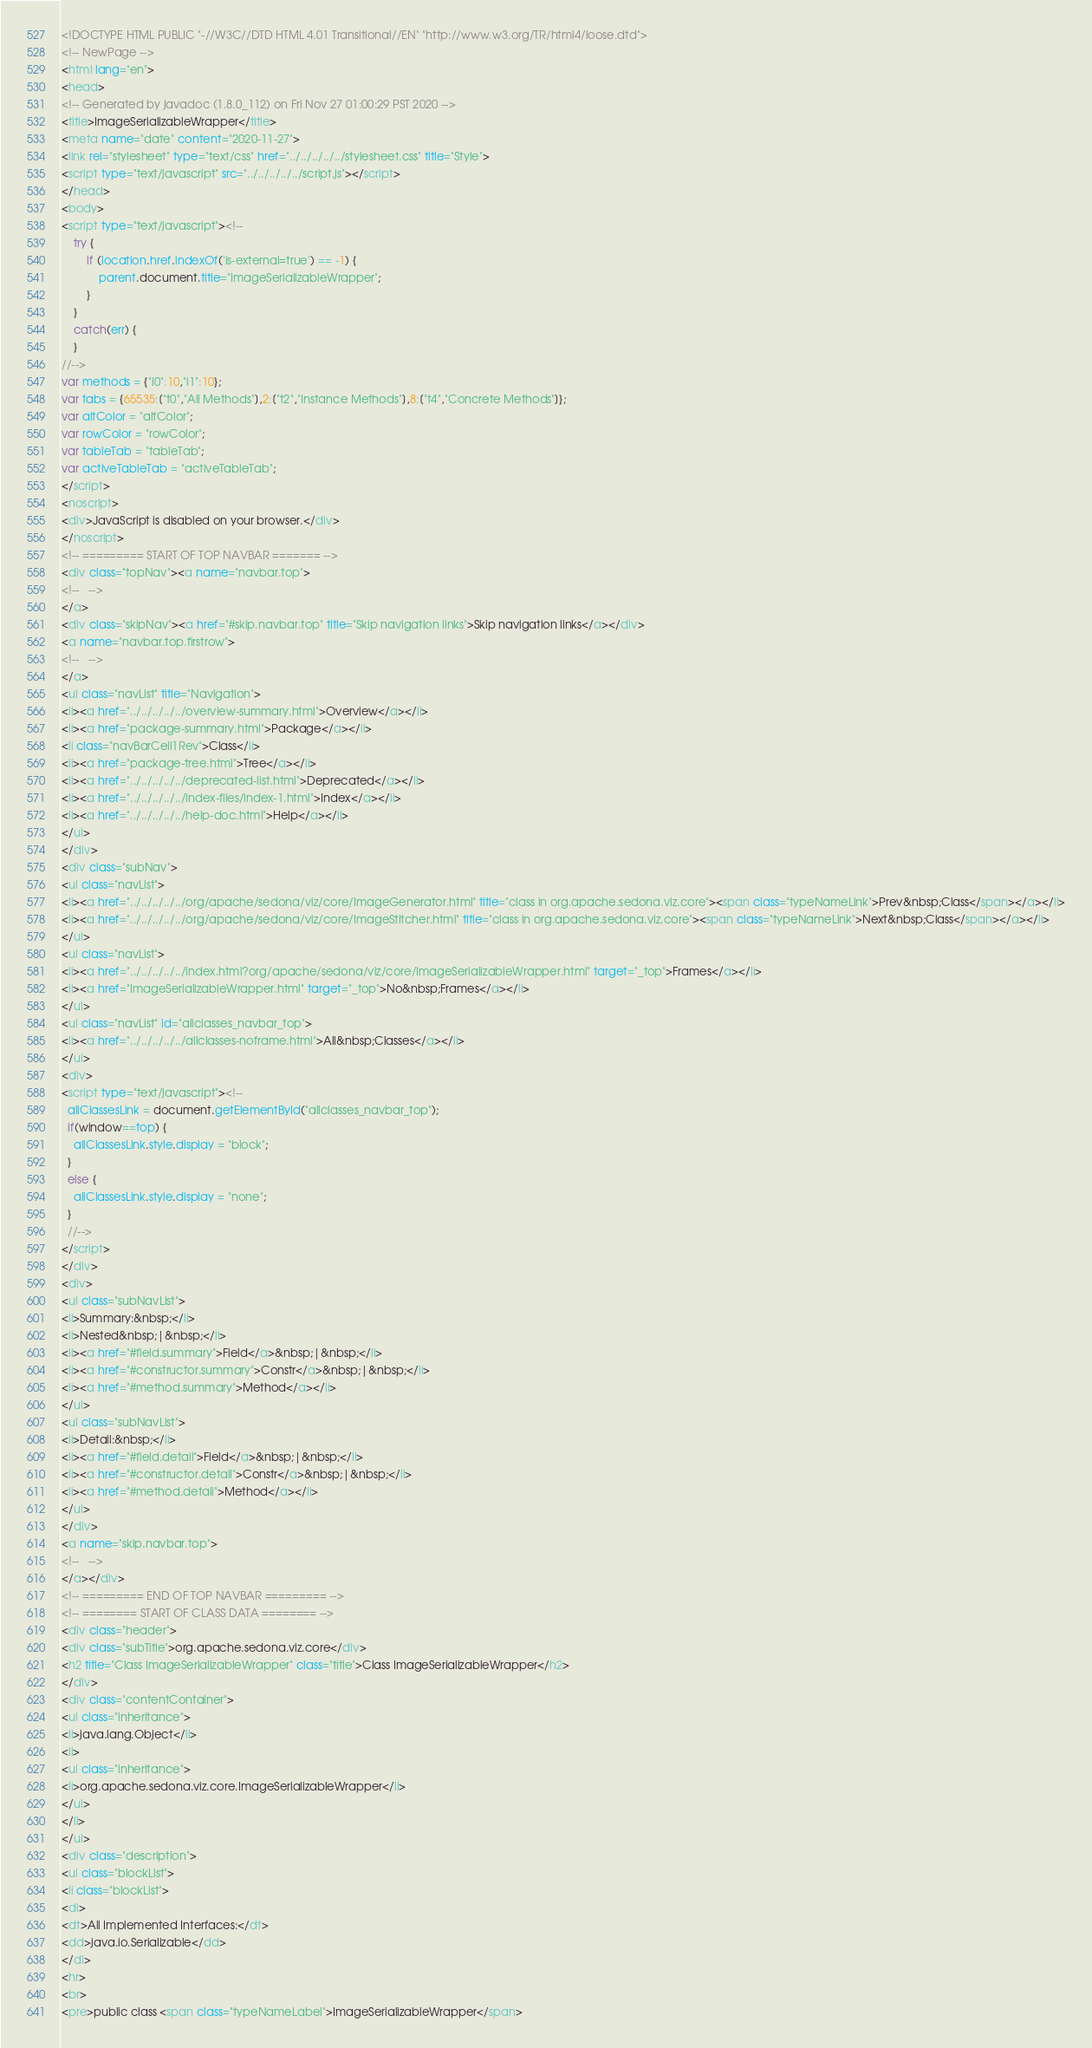Convert code to text. <code><loc_0><loc_0><loc_500><loc_500><_HTML_><!DOCTYPE HTML PUBLIC "-//W3C//DTD HTML 4.01 Transitional//EN" "http://www.w3.org/TR/html4/loose.dtd">
<!-- NewPage -->
<html lang="en">
<head>
<!-- Generated by javadoc (1.8.0_112) on Fri Nov 27 01:00:29 PST 2020 -->
<title>ImageSerializableWrapper</title>
<meta name="date" content="2020-11-27">
<link rel="stylesheet" type="text/css" href="../../../../../stylesheet.css" title="Style">
<script type="text/javascript" src="../../../../../script.js"></script>
</head>
<body>
<script type="text/javascript"><!--
    try {
        if (location.href.indexOf('is-external=true') == -1) {
            parent.document.title="ImageSerializableWrapper";
        }
    }
    catch(err) {
    }
//-->
var methods = {"i0":10,"i1":10};
var tabs = {65535:["t0","All Methods"],2:["t2","Instance Methods"],8:["t4","Concrete Methods"]};
var altColor = "altColor";
var rowColor = "rowColor";
var tableTab = "tableTab";
var activeTableTab = "activeTableTab";
</script>
<noscript>
<div>JavaScript is disabled on your browser.</div>
</noscript>
<!-- ========= START OF TOP NAVBAR ======= -->
<div class="topNav"><a name="navbar.top">
<!--   -->
</a>
<div class="skipNav"><a href="#skip.navbar.top" title="Skip navigation links">Skip navigation links</a></div>
<a name="navbar.top.firstrow">
<!--   -->
</a>
<ul class="navList" title="Navigation">
<li><a href="../../../../../overview-summary.html">Overview</a></li>
<li><a href="package-summary.html">Package</a></li>
<li class="navBarCell1Rev">Class</li>
<li><a href="package-tree.html">Tree</a></li>
<li><a href="../../../../../deprecated-list.html">Deprecated</a></li>
<li><a href="../../../../../index-files/index-1.html">Index</a></li>
<li><a href="../../../../../help-doc.html">Help</a></li>
</ul>
</div>
<div class="subNav">
<ul class="navList">
<li><a href="../../../../../org/apache/sedona/viz/core/ImageGenerator.html" title="class in org.apache.sedona.viz.core"><span class="typeNameLink">Prev&nbsp;Class</span></a></li>
<li><a href="../../../../../org/apache/sedona/viz/core/ImageStitcher.html" title="class in org.apache.sedona.viz.core"><span class="typeNameLink">Next&nbsp;Class</span></a></li>
</ul>
<ul class="navList">
<li><a href="../../../../../index.html?org/apache/sedona/viz/core/ImageSerializableWrapper.html" target="_top">Frames</a></li>
<li><a href="ImageSerializableWrapper.html" target="_top">No&nbsp;Frames</a></li>
</ul>
<ul class="navList" id="allclasses_navbar_top">
<li><a href="../../../../../allclasses-noframe.html">All&nbsp;Classes</a></li>
</ul>
<div>
<script type="text/javascript"><!--
  allClassesLink = document.getElementById("allclasses_navbar_top");
  if(window==top) {
    allClassesLink.style.display = "block";
  }
  else {
    allClassesLink.style.display = "none";
  }
  //-->
</script>
</div>
<div>
<ul class="subNavList">
<li>Summary:&nbsp;</li>
<li>Nested&nbsp;|&nbsp;</li>
<li><a href="#field.summary">Field</a>&nbsp;|&nbsp;</li>
<li><a href="#constructor.summary">Constr</a>&nbsp;|&nbsp;</li>
<li><a href="#method.summary">Method</a></li>
</ul>
<ul class="subNavList">
<li>Detail:&nbsp;</li>
<li><a href="#field.detail">Field</a>&nbsp;|&nbsp;</li>
<li><a href="#constructor.detail">Constr</a>&nbsp;|&nbsp;</li>
<li><a href="#method.detail">Method</a></li>
</ul>
</div>
<a name="skip.navbar.top">
<!--   -->
</a></div>
<!-- ========= END OF TOP NAVBAR ========= -->
<!-- ======== START OF CLASS DATA ======== -->
<div class="header">
<div class="subTitle">org.apache.sedona.viz.core</div>
<h2 title="Class ImageSerializableWrapper" class="title">Class ImageSerializableWrapper</h2>
</div>
<div class="contentContainer">
<ul class="inheritance">
<li>java.lang.Object</li>
<li>
<ul class="inheritance">
<li>org.apache.sedona.viz.core.ImageSerializableWrapper</li>
</ul>
</li>
</ul>
<div class="description">
<ul class="blockList">
<li class="blockList">
<dl>
<dt>All Implemented Interfaces:</dt>
<dd>java.io.Serializable</dd>
</dl>
<hr>
<br>
<pre>public class <span class="typeNameLabel">ImageSerializableWrapper</span></code> 